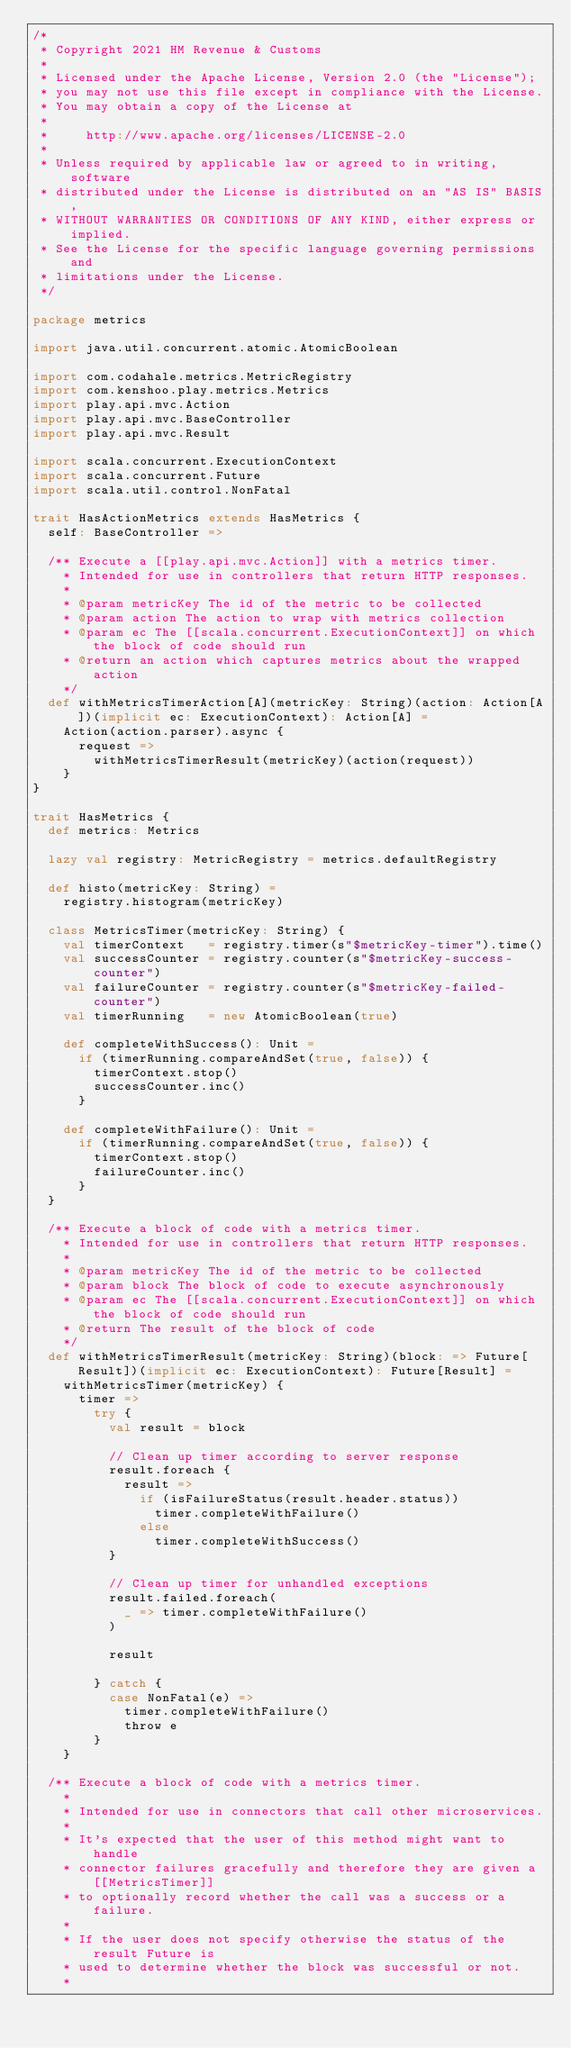<code> <loc_0><loc_0><loc_500><loc_500><_Scala_>/*
 * Copyright 2021 HM Revenue & Customs
 *
 * Licensed under the Apache License, Version 2.0 (the "License");
 * you may not use this file except in compliance with the License.
 * You may obtain a copy of the License at
 *
 *     http://www.apache.org/licenses/LICENSE-2.0
 *
 * Unless required by applicable law or agreed to in writing, software
 * distributed under the License is distributed on an "AS IS" BASIS,
 * WITHOUT WARRANTIES OR CONDITIONS OF ANY KIND, either express or implied.
 * See the License for the specific language governing permissions and
 * limitations under the License.
 */

package metrics

import java.util.concurrent.atomic.AtomicBoolean

import com.codahale.metrics.MetricRegistry
import com.kenshoo.play.metrics.Metrics
import play.api.mvc.Action
import play.api.mvc.BaseController
import play.api.mvc.Result

import scala.concurrent.ExecutionContext
import scala.concurrent.Future
import scala.util.control.NonFatal

trait HasActionMetrics extends HasMetrics {
  self: BaseController =>

  /** Execute a [[play.api.mvc.Action]] with a metrics timer.
    * Intended for use in controllers that return HTTP responses.
    *
    * @param metricKey The id of the metric to be collected
    * @param action The action to wrap with metrics collection
    * @param ec The [[scala.concurrent.ExecutionContext]] on which the block of code should run
    * @return an action which captures metrics about the wrapped action
    */
  def withMetricsTimerAction[A](metricKey: String)(action: Action[A])(implicit ec: ExecutionContext): Action[A] =
    Action(action.parser).async {
      request =>
        withMetricsTimerResult(metricKey)(action(request))
    }
}

trait HasMetrics {
  def metrics: Metrics

  lazy val registry: MetricRegistry = metrics.defaultRegistry

  def histo(metricKey: String) =
    registry.histogram(metricKey)

  class MetricsTimer(metricKey: String) {
    val timerContext   = registry.timer(s"$metricKey-timer").time()
    val successCounter = registry.counter(s"$metricKey-success-counter")
    val failureCounter = registry.counter(s"$metricKey-failed-counter")
    val timerRunning   = new AtomicBoolean(true)

    def completeWithSuccess(): Unit =
      if (timerRunning.compareAndSet(true, false)) {
        timerContext.stop()
        successCounter.inc()
      }

    def completeWithFailure(): Unit =
      if (timerRunning.compareAndSet(true, false)) {
        timerContext.stop()
        failureCounter.inc()
      }
  }

  /** Execute a block of code with a metrics timer.
    * Intended for use in controllers that return HTTP responses.
    *
    * @param metricKey The id of the metric to be collected
    * @param block The block of code to execute asynchronously
    * @param ec The [[scala.concurrent.ExecutionContext]] on which the block of code should run
    * @return The result of the block of code
    */
  def withMetricsTimerResult(metricKey: String)(block: => Future[Result])(implicit ec: ExecutionContext): Future[Result] =
    withMetricsTimer(metricKey) {
      timer =>
        try {
          val result = block

          // Clean up timer according to server response
          result.foreach {
            result =>
              if (isFailureStatus(result.header.status))
                timer.completeWithFailure()
              else
                timer.completeWithSuccess()
          }

          // Clean up timer for unhandled exceptions
          result.failed.foreach(
            _ => timer.completeWithFailure()
          )

          result

        } catch {
          case NonFatal(e) =>
            timer.completeWithFailure()
            throw e
        }
    }

  /** Execute a block of code with a metrics timer.
    *
    * Intended for use in connectors that call other microservices.
    *
    * It's expected that the user of this method might want to handle
    * connector failures gracefully and therefore they are given a [[MetricsTimer]]
    * to optionally record whether the call was a success or a failure.
    *
    * If the user does not specify otherwise the status of the result Future is
    * used to determine whether the block was successful or not.
    *</code> 